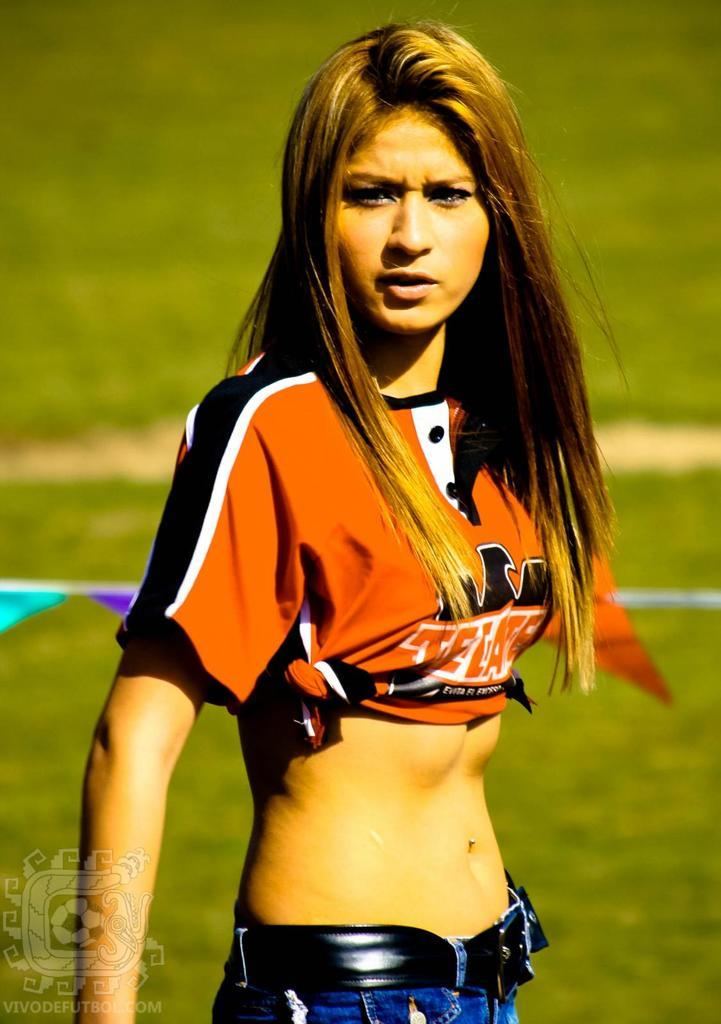What is the main subject of the image? There is a woman standing in the image. What can be seen in the background of the image? There are plants and grass visible in the background of the image. What is located in the bottom left corner of the image? There is a logo and text in the bottom left corner of the image. What type of tin pan can be seen in the woman's hand in the image? There is no tin pan present in the image; the woman's hands are not visible. 